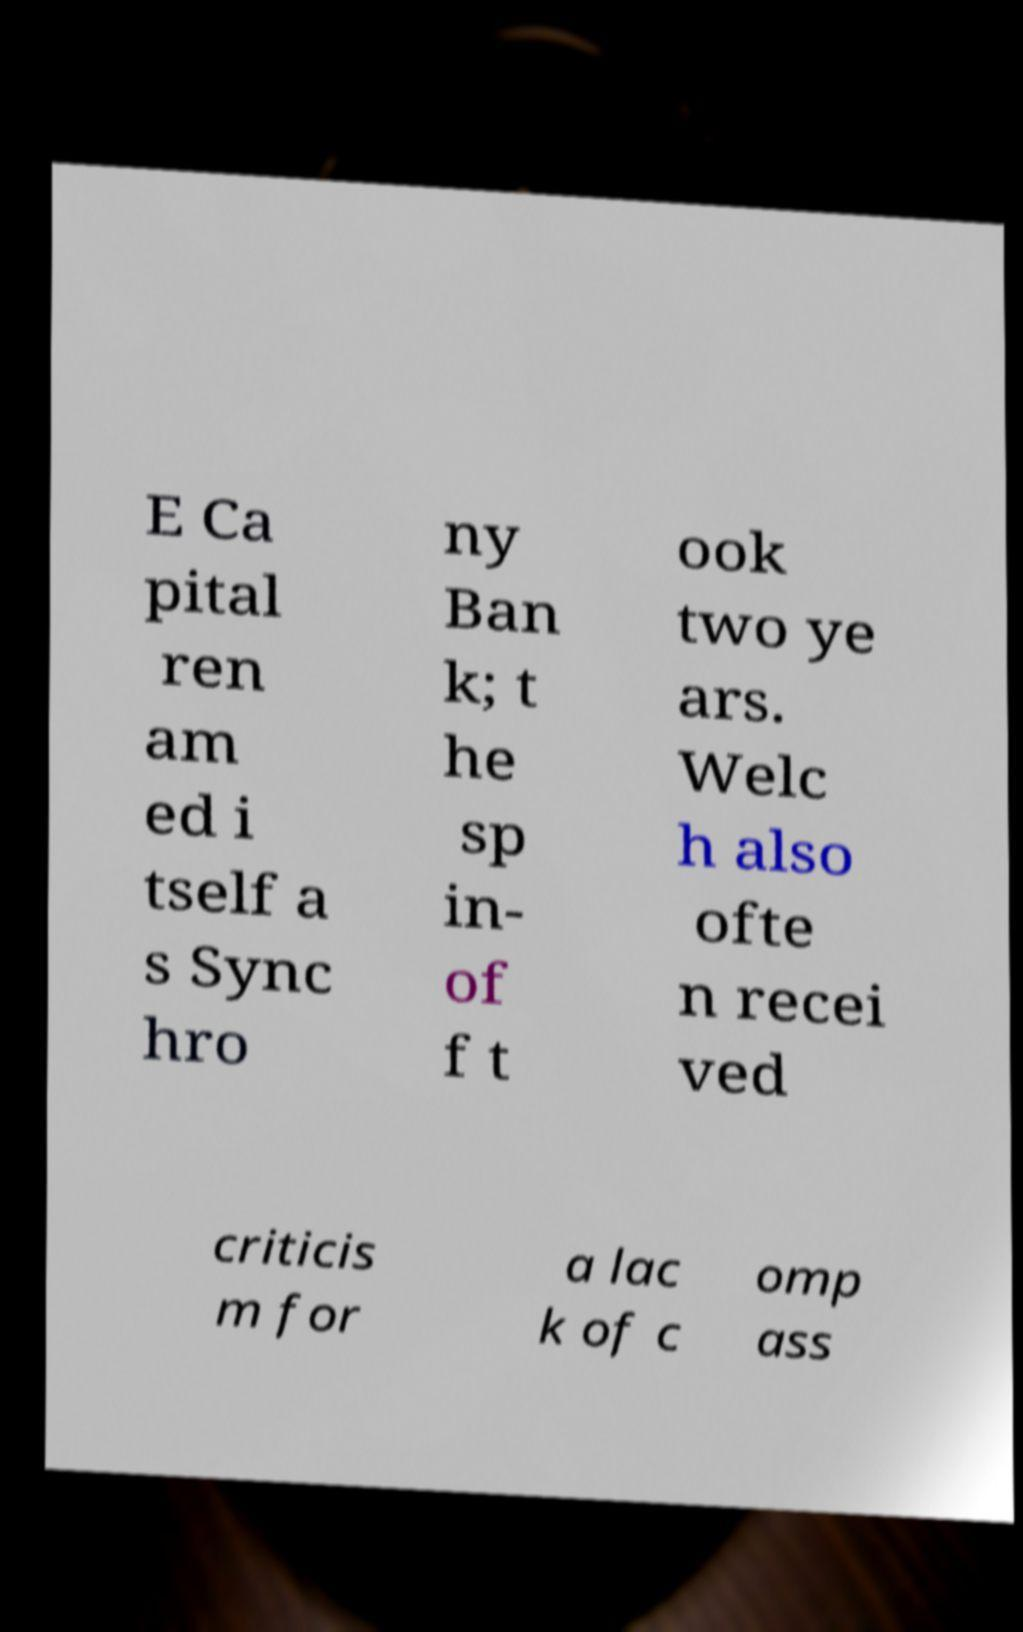For documentation purposes, I need the text within this image transcribed. Could you provide that? E Ca pital ren am ed i tself a s Sync hro ny Ban k; t he sp in- of f t ook two ye ars. Welc h also ofte n recei ved criticis m for a lac k of c omp ass 